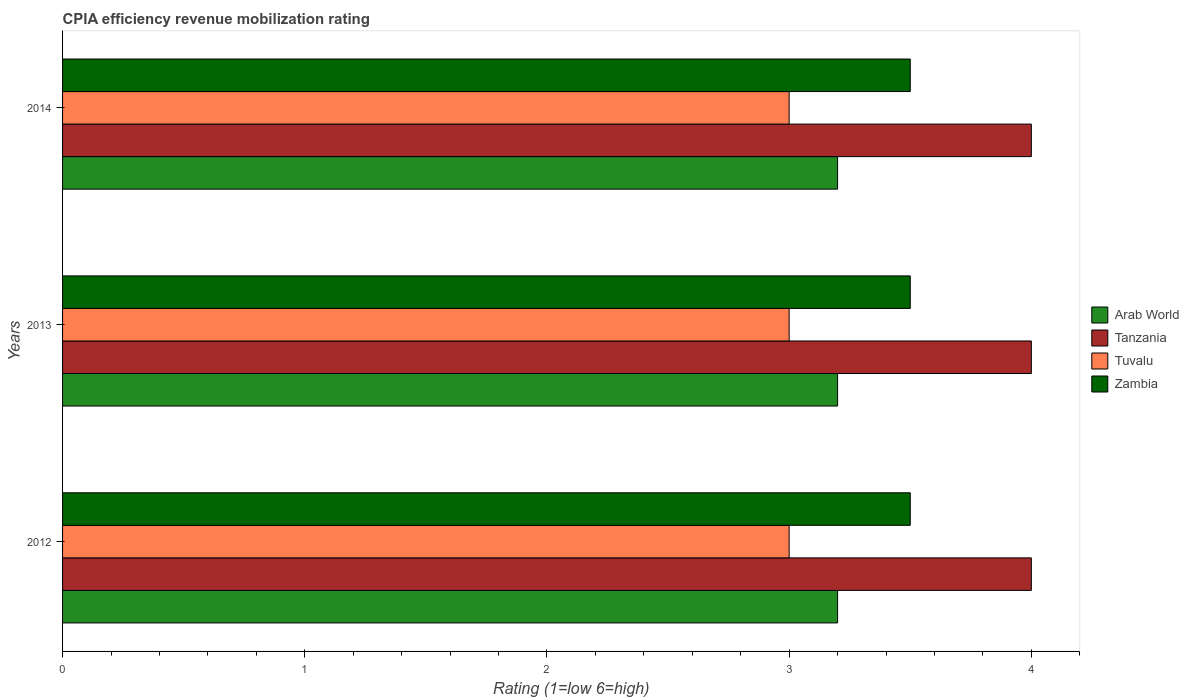How many different coloured bars are there?
Your answer should be compact. 4. How many groups of bars are there?
Your answer should be very brief. 3. How many bars are there on the 3rd tick from the top?
Your answer should be very brief. 4. How many bars are there on the 3rd tick from the bottom?
Provide a short and direct response. 4. In how many cases, is the number of bars for a given year not equal to the number of legend labels?
Ensure brevity in your answer.  0. In which year was the CPIA rating in Arab World maximum?
Provide a succinct answer. 2012. In which year was the CPIA rating in Tuvalu minimum?
Your answer should be compact. 2012. What is the average CPIA rating in Zambia per year?
Keep it short and to the point. 3.5. What is the ratio of the CPIA rating in Tanzania in 2013 to that in 2014?
Make the answer very short. 1. Is the CPIA rating in Arab World in 2013 less than that in 2014?
Offer a very short reply. No. Is the difference between the CPIA rating in Zambia in 2012 and 2014 greater than the difference between the CPIA rating in Tanzania in 2012 and 2014?
Keep it short and to the point. No. What is the difference between the highest and the second highest CPIA rating in Arab World?
Offer a terse response. 0. Is the sum of the CPIA rating in Tanzania in 2012 and 2014 greater than the maximum CPIA rating in Zambia across all years?
Ensure brevity in your answer.  Yes. Is it the case that in every year, the sum of the CPIA rating in Tuvalu and CPIA rating in Zambia is greater than the sum of CPIA rating in Tanzania and CPIA rating in Arab World?
Your answer should be compact. No. What does the 3rd bar from the top in 2013 represents?
Offer a very short reply. Tanzania. What does the 2nd bar from the bottom in 2012 represents?
Provide a succinct answer. Tanzania. Is it the case that in every year, the sum of the CPIA rating in Tuvalu and CPIA rating in Tanzania is greater than the CPIA rating in Arab World?
Ensure brevity in your answer.  Yes. How many bars are there?
Your response must be concise. 12. Are all the bars in the graph horizontal?
Your answer should be compact. Yes. How many years are there in the graph?
Ensure brevity in your answer.  3. What is the difference between two consecutive major ticks on the X-axis?
Keep it short and to the point. 1. Are the values on the major ticks of X-axis written in scientific E-notation?
Offer a very short reply. No. Does the graph contain any zero values?
Offer a terse response. No. Does the graph contain grids?
Give a very brief answer. No. Where does the legend appear in the graph?
Keep it short and to the point. Center right. How many legend labels are there?
Your answer should be very brief. 4. How are the legend labels stacked?
Give a very brief answer. Vertical. What is the title of the graph?
Your answer should be very brief. CPIA efficiency revenue mobilization rating. What is the Rating (1=low 6=high) of Tuvalu in 2014?
Provide a short and direct response. 3. Across all years, what is the maximum Rating (1=low 6=high) of Tuvalu?
Provide a succinct answer. 3. Across all years, what is the maximum Rating (1=low 6=high) of Zambia?
Your response must be concise. 3.5. Across all years, what is the minimum Rating (1=low 6=high) in Tanzania?
Give a very brief answer. 4. Across all years, what is the minimum Rating (1=low 6=high) in Tuvalu?
Your answer should be compact. 3. Across all years, what is the minimum Rating (1=low 6=high) in Zambia?
Provide a succinct answer. 3.5. What is the difference between the Rating (1=low 6=high) in Arab World in 2012 and that in 2013?
Provide a succinct answer. 0. What is the difference between the Rating (1=low 6=high) in Zambia in 2012 and that in 2013?
Your response must be concise. 0. What is the difference between the Rating (1=low 6=high) of Arab World in 2012 and that in 2014?
Offer a terse response. 0. What is the difference between the Rating (1=low 6=high) in Tuvalu in 2012 and that in 2014?
Provide a short and direct response. 0. What is the difference between the Rating (1=low 6=high) in Arab World in 2013 and that in 2014?
Your answer should be compact. 0. What is the difference between the Rating (1=low 6=high) of Zambia in 2013 and that in 2014?
Offer a very short reply. 0. What is the difference between the Rating (1=low 6=high) of Arab World in 2012 and the Rating (1=low 6=high) of Tanzania in 2013?
Provide a short and direct response. -0.8. What is the difference between the Rating (1=low 6=high) of Arab World in 2012 and the Rating (1=low 6=high) of Tuvalu in 2013?
Your answer should be very brief. 0.2. What is the difference between the Rating (1=low 6=high) of Arab World in 2012 and the Rating (1=low 6=high) of Zambia in 2013?
Provide a short and direct response. -0.3. What is the difference between the Rating (1=low 6=high) of Tanzania in 2012 and the Rating (1=low 6=high) of Tuvalu in 2013?
Your answer should be very brief. 1. What is the difference between the Rating (1=low 6=high) in Tanzania in 2012 and the Rating (1=low 6=high) in Zambia in 2013?
Your response must be concise. 0.5. What is the difference between the Rating (1=low 6=high) in Tuvalu in 2012 and the Rating (1=low 6=high) in Zambia in 2013?
Your answer should be very brief. -0.5. What is the difference between the Rating (1=low 6=high) of Arab World in 2012 and the Rating (1=low 6=high) of Tanzania in 2014?
Provide a short and direct response. -0.8. What is the difference between the Rating (1=low 6=high) in Arab World in 2012 and the Rating (1=low 6=high) in Tuvalu in 2014?
Offer a very short reply. 0.2. What is the difference between the Rating (1=low 6=high) of Arab World in 2012 and the Rating (1=low 6=high) of Zambia in 2014?
Offer a terse response. -0.3. What is the difference between the Rating (1=low 6=high) of Tanzania in 2012 and the Rating (1=low 6=high) of Tuvalu in 2014?
Give a very brief answer. 1. What is the difference between the Rating (1=low 6=high) of Arab World in 2013 and the Rating (1=low 6=high) of Tanzania in 2014?
Offer a very short reply. -0.8. What is the difference between the Rating (1=low 6=high) of Arab World in 2013 and the Rating (1=low 6=high) of Zambia in 2014?
Make the answer very short. -0.3. What is the difference between the Rating (1=low 6=high) of Tanzania in 2013 and the Rating (1=low 6=high) of Tuvalu in 2014?
Keep it short and to the point. 1. What is the average Rating (1=low 6=high) in Tanzania per year?
Provide a short and direct response. 4. What is the average Rating (1=low 6=high) in Tuvalu per year?
Ensure brevity in your answer.  3. In the year 2012, what is the difference between the Rating (1=low 6=high) of Arab World and Rating (1=low 6=high) of Tuvalu?
Give a very brief answer. 0.2. In the year 2012, what is the difference between the Rating (1=low 6=high) in Arab World and Rating (1=low 6=high) in Zambia?
Provide a succinct answer. -0.3. In the year 2012, what is the difference between the Rating (1=low 6=high) in Tanzania and Rating (1=low 6=high) in Zambia?
Offer a terse response. 0.5. In the year 2012, what is the difference between the Rating (1=low 6=high) in Tuvalu and Rating (1=low 6=high) in Zambia?
Make the answer very short. -0.5. In the year 2013, what is the difference between the Rating (1=low 6=high) of Arab World and Rating (1=low 6=high) of Tanzania?
Keep it short and to the point. -0.8. In the year 2013, what is the difference between the Rating (1=low 6=high) in Tanzania and Rating (1=low 6=high) in Tuvalu?
Give a very brief answer. 1. In the year 2013, what is the difference between the Rating (1=low 6=high) of Tuvalu and Rating (1=low 6=high) of Zambia?
Ensure brevity in your answer.  -0.5. In the year 2014, what is the difference between the Rating (1=low 6=high) in Arab World and Rating (1=low 6=high) in Tanzania?
Offer a terse response. -0.8. In the year 2014, what is the difference between the Rating (1=low 6=high) of Arab World and Rating (1=low 6=high) of Tuvalu?
Offer a very short reply. 0.2. In the year 2014, what is the difference between the Rating (1=low 6=high) of Arab World and Rating (1=low 6=high) of Zambia?
Give a very brief answer. -0.3. In the year 2014, what is the difference between the Rating (1=low 6=high) in Tanzania and Rating (1=low 6=high) in Tuvalu?
Offer a terse response. 1. In the year 2014, what is the difference between the Rating (1=low 6=high) of Tuvalu and Rating (1=low 6=high) of Zambia?
Your answer should be very brief. -0.5. What is the ratio of the Rating (1=low 6=high) of Arab World in 2012 to that in 2013?
Keep it short and to the point. 1. What is the ratio of the Rating (1=low 6=high) of Tanzania in 2012 to that in 2013?
Make the answer very short. 1. What is the ratio of the Rating (1=low 6=high) in Tuvalu in 2012 to that in 2013?
Your answer should be compact. 1. What is the ratio of the Rating (1=low 6=high) in Zambia in 2012 to that in 2013?
Give a very brief answer. 1. What is the ratio of the Rating (1=low 6=high) of Arab World in 2012 to that in 2014?
Keep it short and to the point. 1. What is the ratio of the Rating (1=low 6=high) in Zambia in 2012 to that in 2014?
Your response must be concise. 1. What is the ratio of the Rating (1=low 6=high) in Arab World in 2013 to that in 2014?
Ensure brevity in your answer.  1. What is the ratio of the Rating (1=low 6=high) in Tuvalu in 2013 to that in 2014?
Offer a terse response. 1. What is the ratio of the Rating (1=low 6=high) in Zambia in 2013 to that in 2014?
Your response must be concise. 1. What is the difference between the highest and the second highest Rating (1=low 6=high) of Tanzania?
Make the answer very short. 0. What is the difference between the highest and the second highest Rating (1=low 6=high) of Tuvalu?
Offer a terse response. 0. What is the difference between the highest and the lowest Rating (1=low 6=high) in Tuvalu?
Ensure brevity in your answer.  0. 